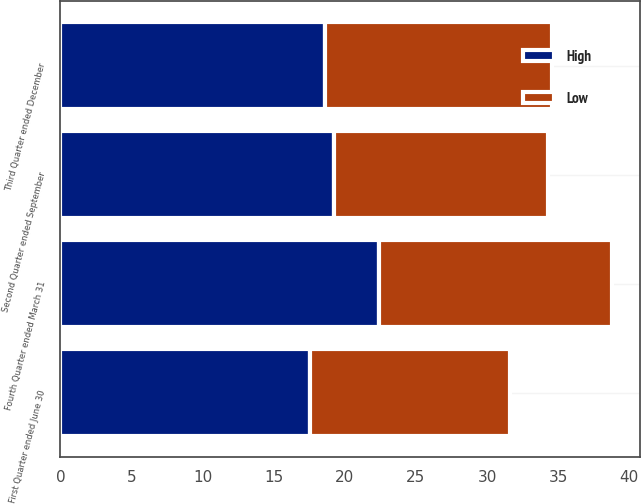Convert chart to OTSL. <chart><loc_0><loc_0><loc_500><loc_500><stacked_bar_chart><ecel><fcel>First Quarter ended June 30<fcel>Second Quarter ended September<fcel>Third Quarter ended December<fcel>Fourth Quarter ended March 31<nl><fcel>High<fcel>17.54<fcel>19.25<fcel>18.59<fcel>22.41<nl><fcel>Low<fcel>14.08<fcel>15.05<fcel>16<fcel>16.4<nl></chart> 